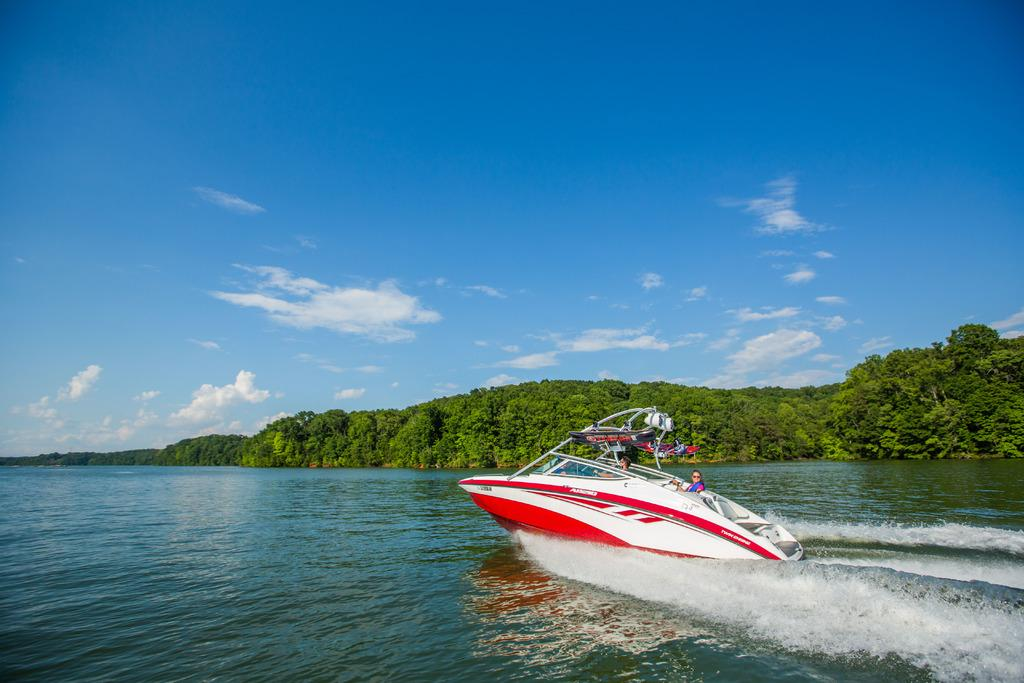What is the main subject of the image? The main subject of the image is a ship sailing on a water surface. What can be seen on the water surface? A ship is sailing on the water surface. How many people are inside the ship? There are two people inside the ship. What is visible in the background of the image? There are plenty of trees in the background of the image. What type of bomb is being dropped from the ship in the image? There is no bomb being dropped from the ship in the image; it is simply sailing on the water surface. How does the digestion of the people inside the ship affect their ability to sail? The digestion of the people inside the ship is not mentioned or relevant to the image, as it only shows a ship sailing on the water surface with two people inside. 